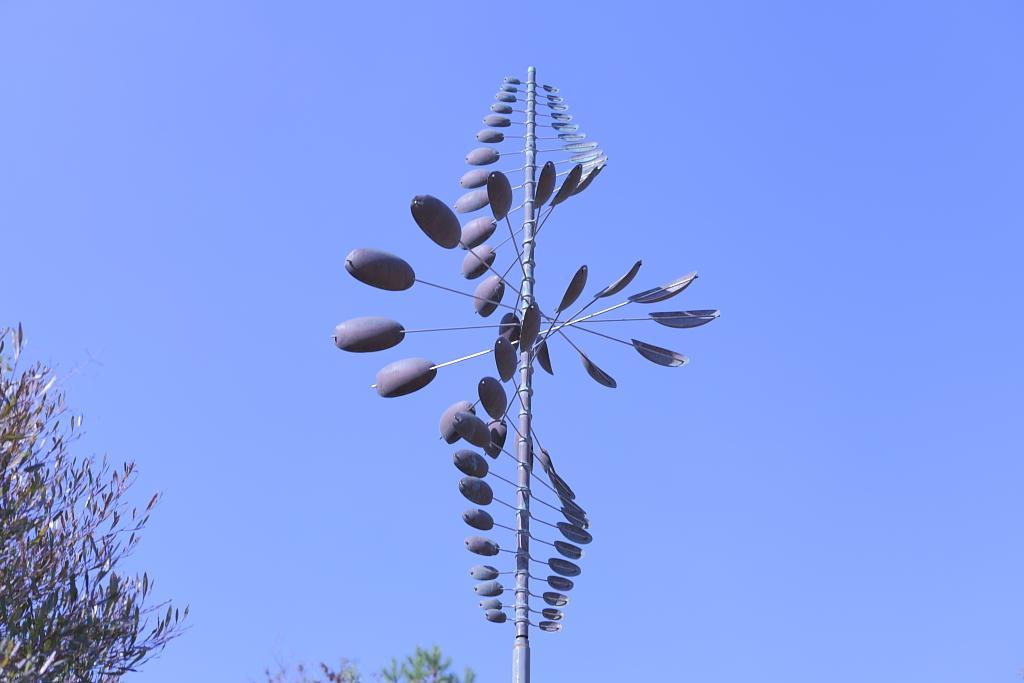In one or two sentences, can you explain what this image depicts? In this picture we can see a copper and steel sculpture(Twister oval). We can see a few trees. 